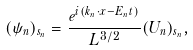<formula> <loc_0><loc_0><loc_500><loc_500>( \psi _ { n } ) _ { s _ { n } } = \frac { e ^ { i ( k _ { n } \cdot x - E _ { n } t ) } } { L ^ { 3 / 2 } } ( U _ { n } ) _ { s _ { n } } ,</formula> 